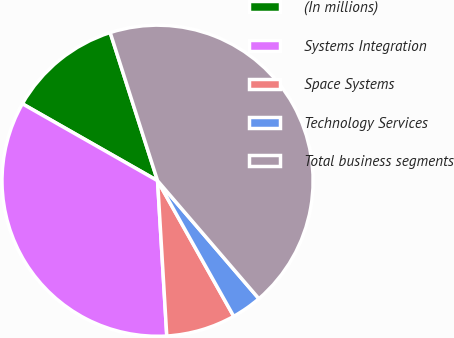Convert chart to OTSL. <chart><loc_0><loc_0><loc_500><loc_500><pie_chart><fcel>(In millions)<fcel>Systems Integration<fcel>Space Systems<fcel>Technology Services<fcel>Total business segments<nl><fcel>11.84%<fcel>34.18%<fcel>7.2%<fcel>3.15%<fcel>43.63%<nl></chart> 